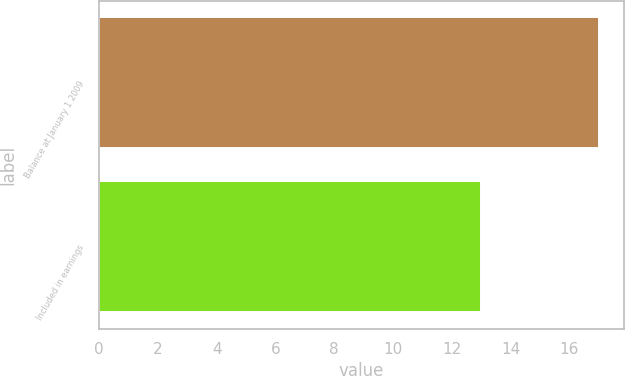Convert chart to OTSL. <chart><loc_0><loc_0><loc_500><loc_500><bar_chart><fcel>Balance at January 1 2009<fcel>Included in earnings<nl><fcel>17<fcel>13<nl></chart> 